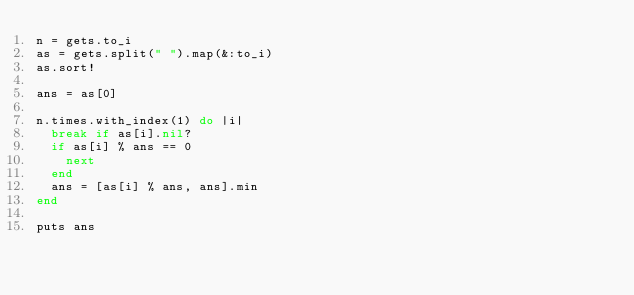<code> <loc_0><loc_0><loc_500><loc_500><_Ruby_>n = gets.to_i
as = gets.split(" ").map(&:to_i)
as.sort!

ans = as[0]

n.times.with_index(1) do |i|
  break if as[i].nil?
  if as[i] % ans == 0
    next
  end
  ans = [as[i] % ans, ans].min
end

puts ans</code> 